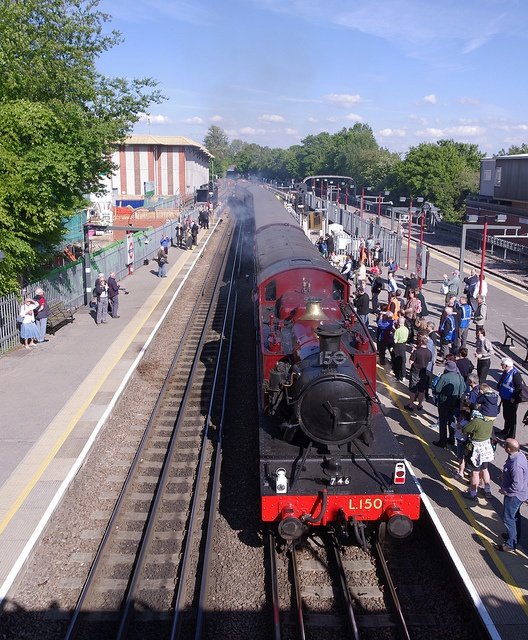Describe the objects in this image and their specific colors. I can see train in gray, black, and purple tones, people in gray, black, darkgray, and navy tones, people in gray, black, violet, and navy tones, people in gray, black, and lavender tones, and people in gray, black, and blue tones in this image. 